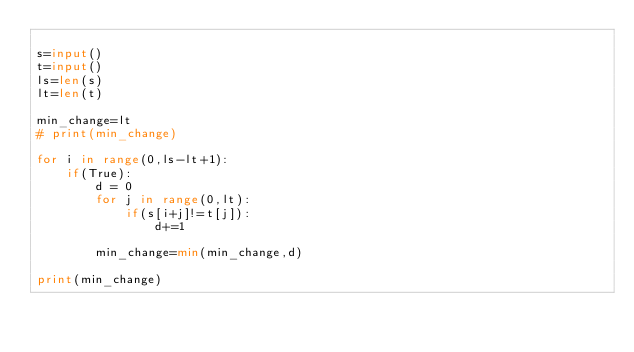Convert code to text. <code><loc_0><loc_0><loc_500><loc_500><_Python_>
s=input()
t=input()
ls=len(s)
lt=len(t)

min_change=lt
# print(min_change)

for i in range(0,ls-lt+1):
    if(True):
        d = 0
        for j in range(0,lt):
            if(s[i+j]!=t[j]):
                d+=1

        min_change=min(min_change,d)

print(min_change)
</code> 